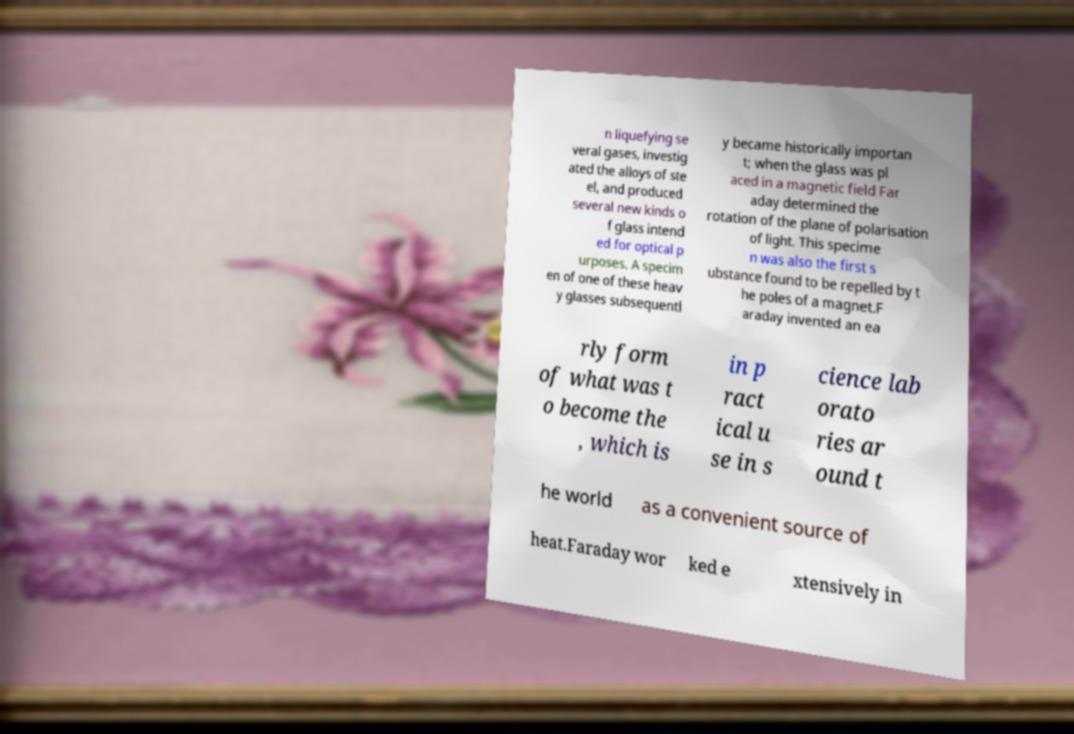Could you extract and type out the text from this image? n liquefying se veral gases, investig ated the alloys of ste el, and produced several new kinds o f glass intend ed for optical p urposes. A specim en of one of these heav y glasses subsequentl y became historically importan t; when the glass was pl aced in a magnetic field Far aday determined the rotation of the plane of polarisation of light. This specime n was also the first s ubstance found to be repelled by t he poles of a magnet.F araday invented an ea rly form of what was t o become the , which is in p ract ical u se in s cience lab orato ries ar ound t he world as a convenient source of heat.Faraday wor ked e xtensively in 